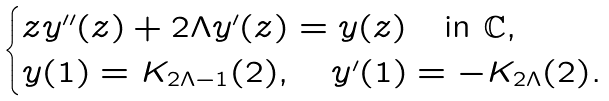Convert formula to latex. <formula><loc_0><loc_0><loc_500><loc_500>\begin{cases} z y ^ { \prime \prime } ( z ) + 2 \Lambda y ^ { \prime } ( z ) = y ( z ) \quad \text {in $\mathbb{C}$,} \\ y ( 1 ) = K _ { 2 \Lambda - 1 } ( 2 ) , \quad y ^ { \prime } ( 1 ) = - K _ { 2 \Lambda } ( 2 ) . \end{cases}</formula> 